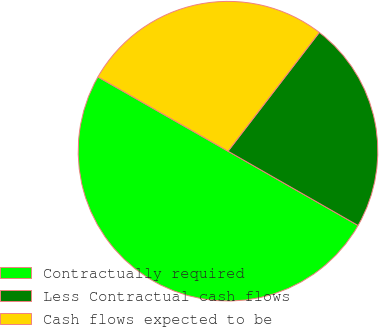Convert chart. <chart><loc_0><loc_0><loc_500><loc_500><pie_chart><fcel>Contractually required<fcel>Less Contractual cash flows<fcel>Cash flows expected to be<nl><fcel>50.0%<fcel>22.83%<fcel>27.17%<nl></chart> 